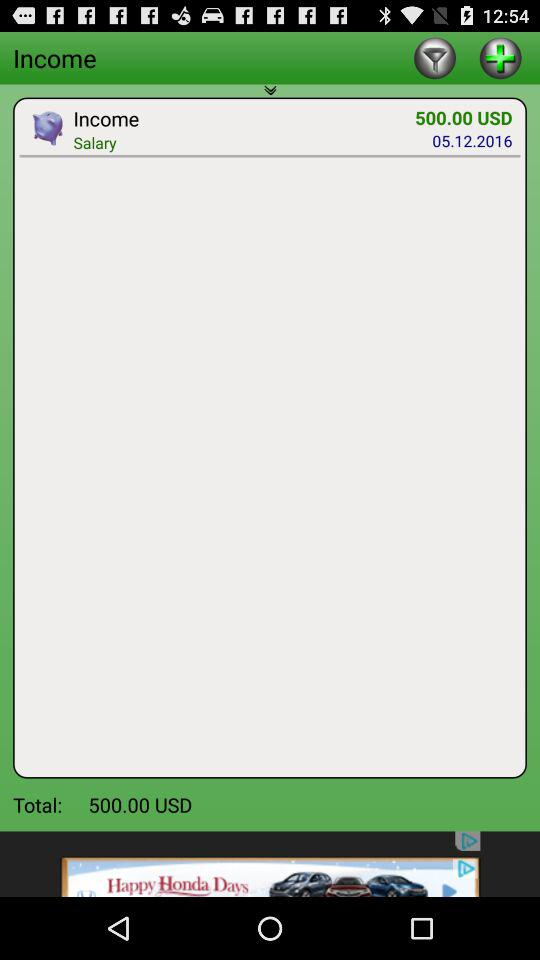What is the total amount of money in this transaction?
Answer the question using a single word or phrase. 500.00 USD 